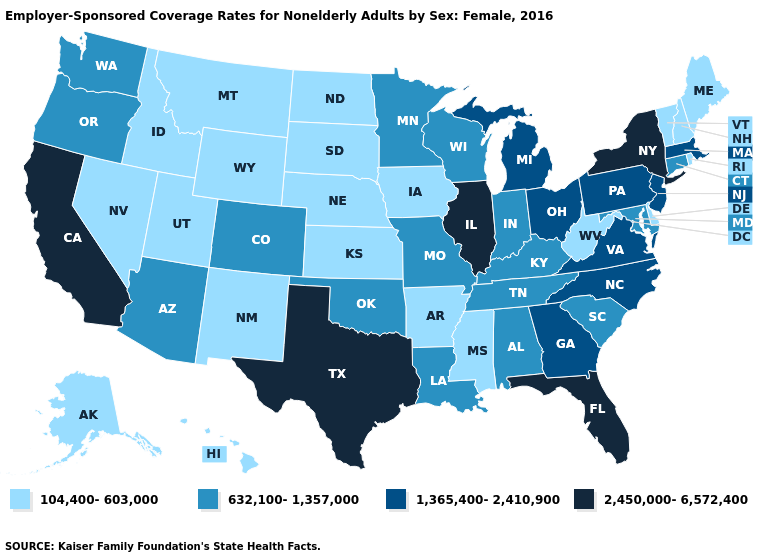Name the states that have a value in the range 2,450,000-6,572,400?
Give a very brief answer. California, Florida, Illinois, New York, Texas. What is the value of Illinois?
Be succinct. 2,450,000-6,572,400. Does Maine have the lowest value in the Northeast?
Be succinct. Yes. Which states have the lowest value in the USA?
Short answer required. Alaska, Arkansas, Delaware, Hawaii, Idaho, Iowa, Kansas, Maine, Mississippi, Montana, Nebraska, Nevada, New Hampshire, New Mexico, North Dakota, Rhode Island, South Dakota, Utah, Vermont, West Virginia, Wyoming. Does Alabama have the same value as Idaho?
Write a very short answer. No. What is the value of New Jersey?
Be succinct. 1,365,400-2,410,900. What is the value of Rhode Island?
Answer briefly. 104,400-603,000. Among the states that border Nevada , does California have the highest value?
Concise answer only. Yes. Does the map have missing data?
Answer briefly. No. Does Alabama have the highest value in the USA?
Give a very brief answer. No. What is the lowest value in states that border New York?
Be succinct. 104,400-603,000. Does Mississippi have the same value as West Virginia?
Keep it brief. Yes. How many symbols are there in the legend?
Be succinct. 4. Among the states that border Utah , which have the lowest value?
Concise answer only. Idaho, Nevada, New Mexico, Wyoming. Name the states that have a value in the range 1,365,400-2,410,900?
Quick response, please. Georgia, Massachusetts, Michigan, New Jersey, North Carolina, Ohio, Pennsylvania, Virginia. 